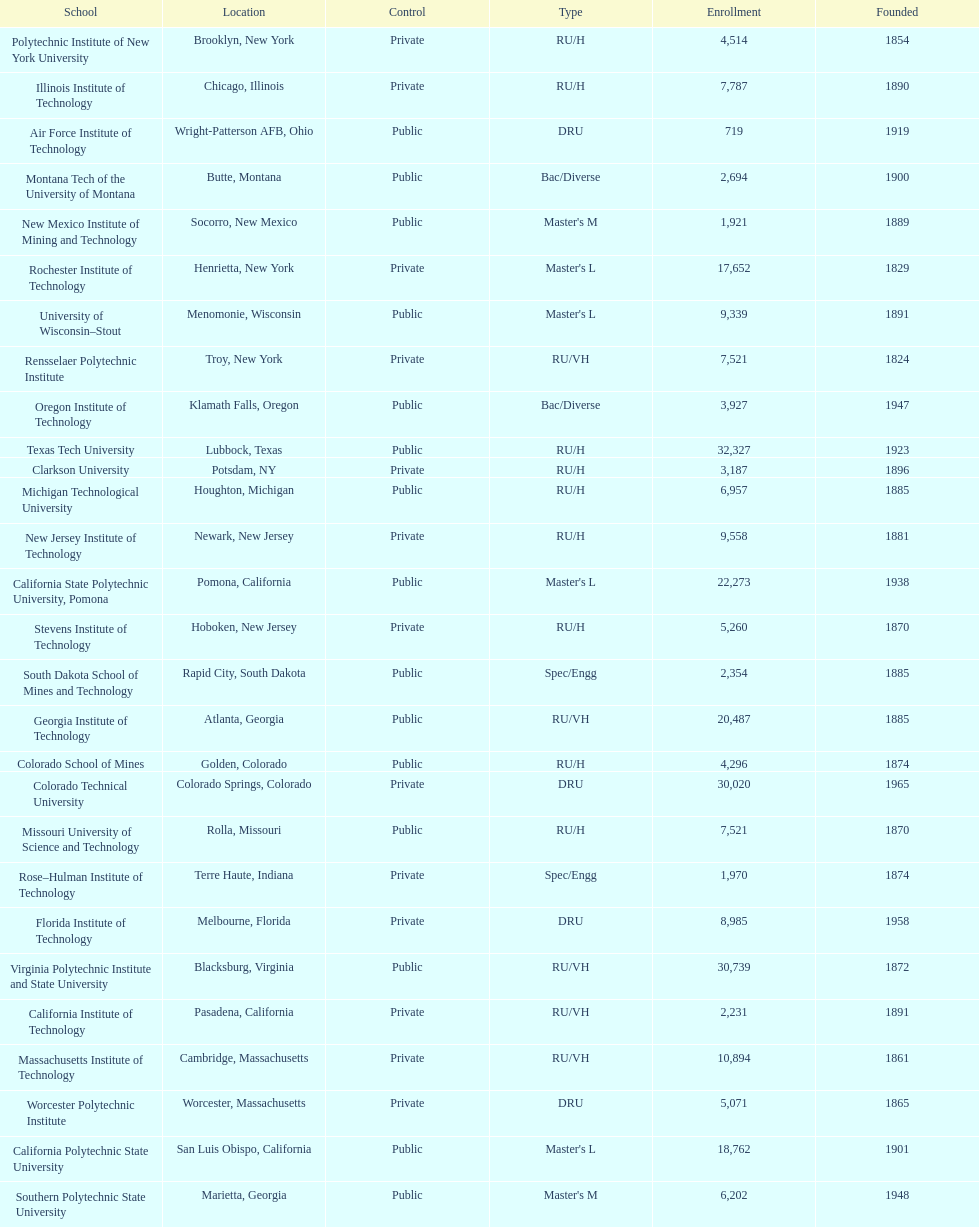What technical universities are in the united states? Air Force Institute of Technology, California Institute of Technology, California Polytechnic State University, California State Polytechnic University, Pomona, Clarkson University, Colorado School of Mines, Colorado Technical University, Florida Institute of Technology, Georgia Institute of Technology, Illinois Institute of Technology, Massachusetts Institute of Technology, Michigan Technological University, Missouri University of Science and Technology, Montana Tech of the University of Montana, New Jersey Institute of Technology, New Mexico Institute of Mining and Technology, Oregon Institute of Technology, Polytechnic Institute of New York University, Rensselaer Polytechnic Institute, Rochester Institute of Technology, Rose–Hulman Institute of Technology, South Dakota School of Mines and Technology, Southern Polytechnic State University, Stevens Institute of Technology, Texas Tech University, University of Wisconsin–Stout, Virginia Polytechnic Institute and State University, Worcester Polytechnic Institute. Could you parse the entire table? {'header': ['School', 'Location', 'Control', 'Type', 'Enrollment', 'Founded'], 'rows': [['Polytechnic Institute of New York University', 'Brooklyn, New York', 'Private', 'RU/H', '4,514', '1854'], ['Illinois Institute of Technology', 'Chicago, Illinois', 'Private', 'RU/H', '7,787', '1890'], ['Air Force Institute of Technology', 'Wright-Patterson AFB, Ohio', 'Public', 'DRU', '719', '1919'], ['Montana Tech of the University of Montana', 'Butte, Montana', 'Public', 'Bac/Diverse', '2,694', '1900'], ['New Mexico Institute of Mining and Technology', 'Socorro, New Mexico', 'Public', "Master's M", '1,921', '1889'], ['Rochester Institute of Technology', 'Henrietta, New York', 'Private', "Master's L", '17,652', '1829'], ['University of Wisconsin–Stout', 'Menomonie, Wisconsin', 'Public', "Master's L", '9,339', '1891'], ['Rensselaer Polytechnic Institute', 'Troy, New York', 'Private', 'RU/VH', '7,521', '1824'], ['Oregon Institute of Technology', 'Klamath Falls, Oregon', 'Public', 'Bac/Diverse', '3,927', '1947'], ['Texas Tech University', 'Lubbock, Texas', 'Public', 'RU/H', '32,327', '1923'], ['Clarkson University', 'Potsdam, NY', 'Private', 'RU/H', '3,187', '1896'], ['Michigan Technological University', 'Houghton, Michigan', 'Public', 'RU/H', '6,957', '1885'], ['New Jersey Institute of Technology', 'Newark, New Jersey', 'Private', 'RU/H', '9,558', '1881'], ['California State Polytechnic University, Pomona', 'Pomona, California', 'Public', "Master's L", '22,273', '1938'], ['Stevens Institute of Technology', 'Hoboken, New Jersey', 'Private', 'RU/H', '5,260', '1870'], ['South Dakota School of Mines and Technology', 'Rapid City, South Dakota', 'Public', 'Spec/Engg', '2,354', '1885'], ['Georgia Institute of Technology', 'Atlanta, Georgia', 'Public', 'RU/VH', '20,487', '1885'], ['Colorado School of Mines', 'Golden, Colorado', 'Public', 'RU/H', '4,296', '1874'], ['Colorado Technical University', 'Colorado Springs, Colorado', 'Private', 'DRU', '30,020', '1965'], ['Missouri University of Science and Technology', 'Rolla, Missouri', 'Public', 'RU/H', '7,521', '1870'], ['Rose–Hulman Institute of Technology', 'Terre Haute, Indiana', 'Private', 'Spec/Engg', '1,970', '1874'], ['Florida Institute of Technology', 'Melbourne, Florida', 'Private', 'DRU', '8,985', '1958'], ['Virginia Polytechnic Institute and State University', 'Blacksburg, Virginia', 'Public', 'RU/VH', '30,739', '1872'], ['California Institute of Technology', 'Pasadena, California', 'Private', 'RU/VH', '2,231', '1891'], ['Massachusetts Institute of Technology', 'Cambridge, Massachusetts', 'Private', 'RU/VH', '10,894', '1861'], ['Worcester Polytechnic Institute', 'Worcester, Massachusetts', 'Private', 'DRU', '5,071', '1865'], ['California Polytechnic State University', 'San Luis Obispo, California', 'Public', "Master's L", '18,762', '1901'], ['Southern Polytechnic State University', 'Marietta, Georgia', 'Public', "Master's M", '6,202', '1948']]} Which has the highest enrollment? Texas Tech University. 